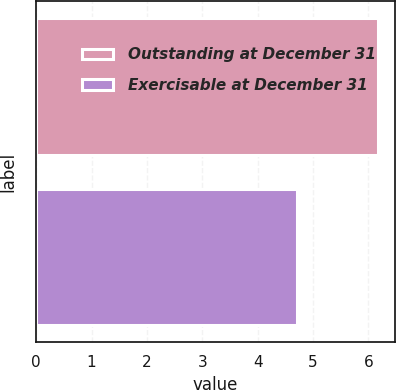<chart> <loc_0><loc_0><loc_500><loc_500><bar_chart><fcel>Outstanding at December 31<fcel>Exercisable at December 31<nl><fcel>6.17<fcel>4.72<nl></chart> 